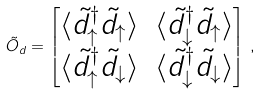<formula> <loc_0><loc_0><loc_500><loc_500>\tilde { O } _ { d } = \begin{bmatrix} \langle \tilde { d } ^ { \dagger } _ { \uparrow } \tilde { d } _ { \uparrow } \rangle & \langle \tilde { d } ^ { \dagger } _ { \downarrow } \tilde { d } _ { \uparrow } \rangle \\ \langle \tilde { d } ^ { \dagger } _ { \uparrow } \tilde { d } _ { \downarrow } \rangle & \langle \tilde { d } ^ { \dagger } _ { \downarrow } \tilde { d } _ { \downarrow } \rangle \end{bmatrix} \, ,</formula> 